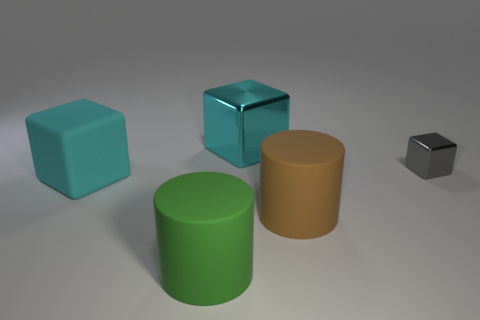Add 1 big shiny objects. How many objects exist? 6 Subtract all blocks. How many objects are left? 2 Add 2 gray metal cubes. How many gray metal cubes are left? 3 Add 4 big cyan things. How many big cyan things exist? 6 Subtract 1 green cylinders. How many objects are left? 4 Subtract all big metallic objects. Subtract all brown rubber cylinders. How many objects are left? 3 